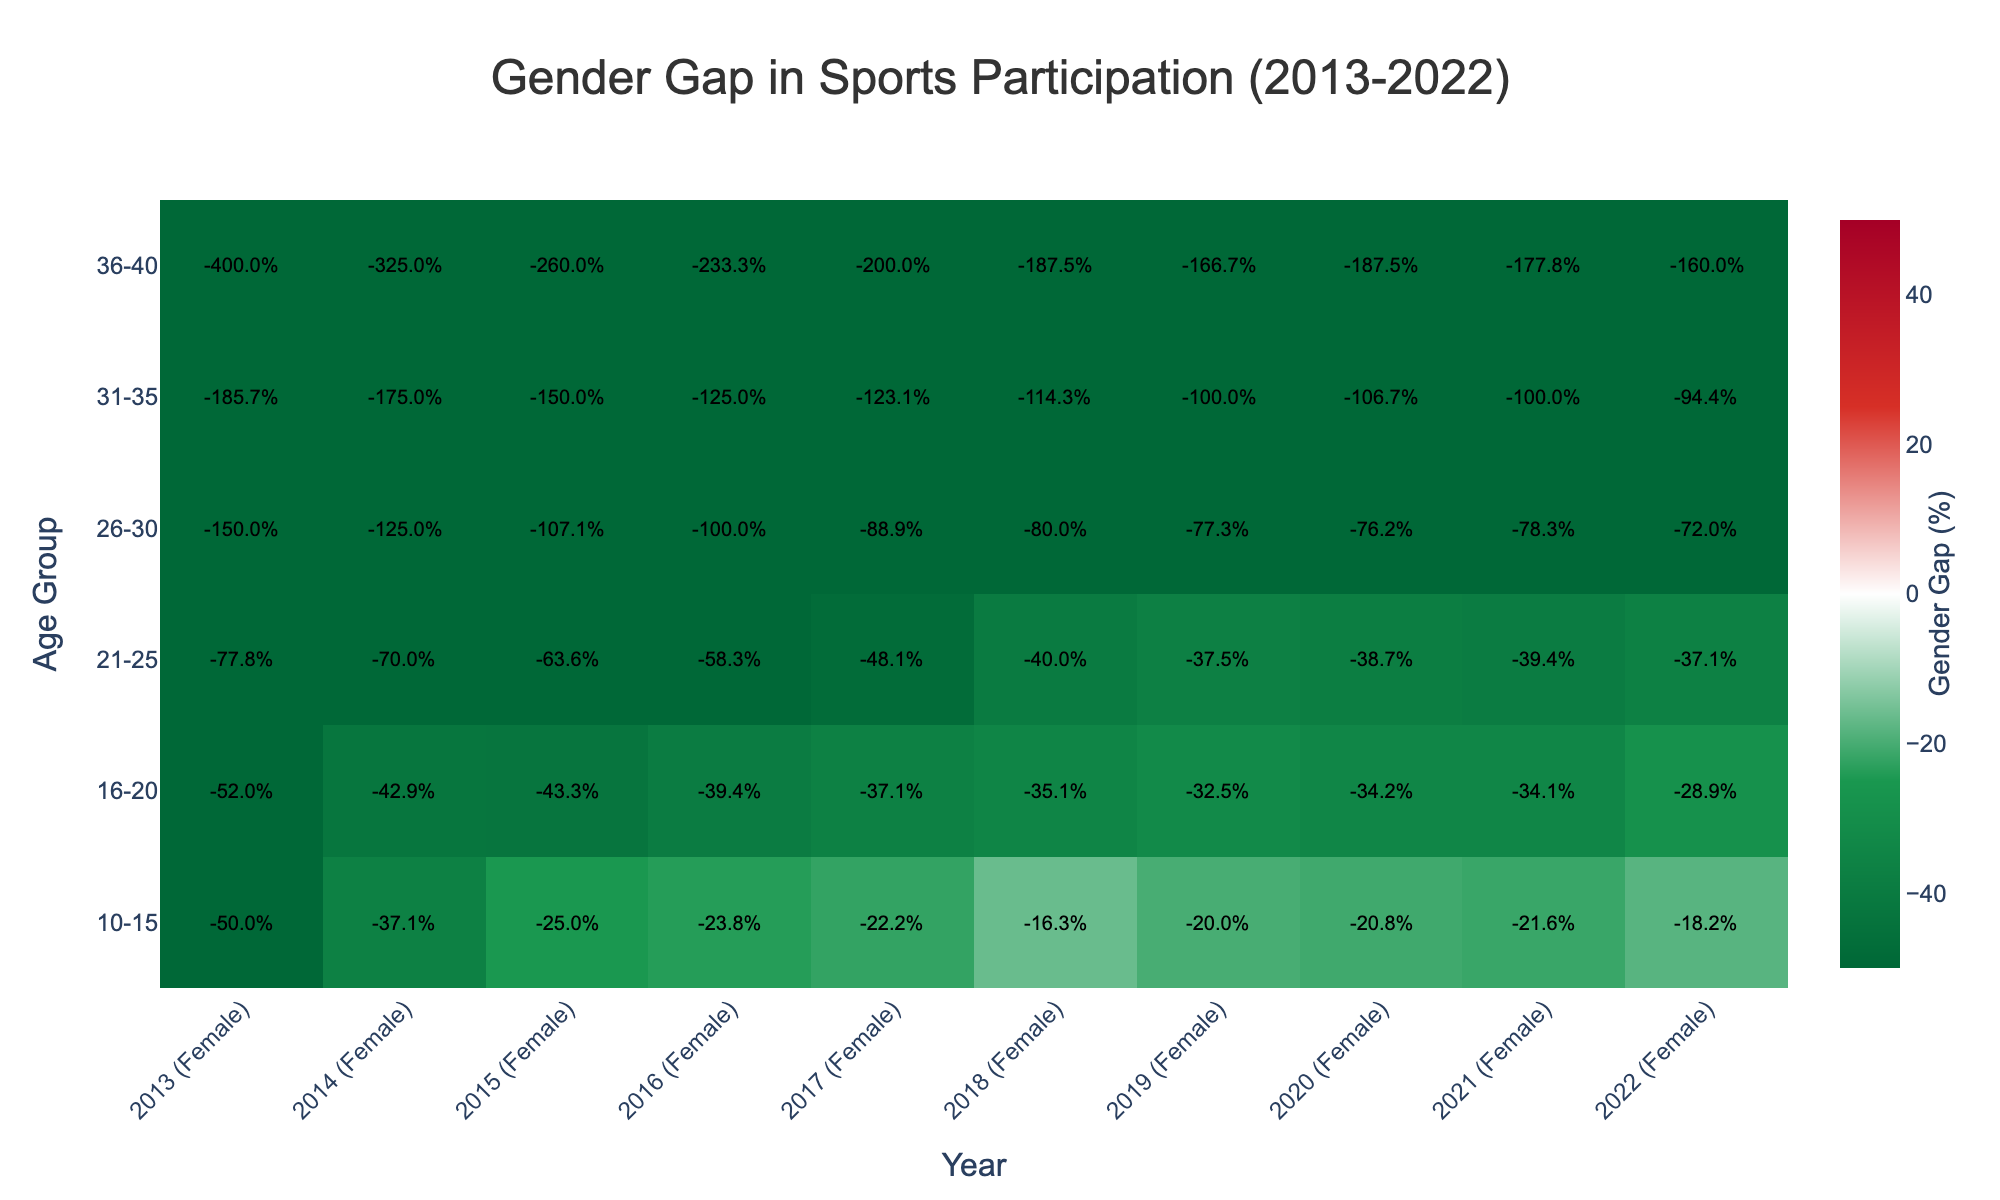What is the title of the heatmap? The title is typically found at the top of the figure and it summarizes the main topic or purpose of the visual representation. In this case, the title is "Gender Gap in Sports Participation (2013-2022)."
Answer: Gender Gap in Sports Participation (2013-2022) How are the years represented on the x-axis formatted? The x-axis in the heatmap lists the years in combination with the gender, formatted as "Year (Gender)." For example, you would see labels like "2013 (Male)" and "2013 (Female)." This indicates the gender-specific participation count for each year.
Answer: Year (Gender) Which age group shows the smallest gender gap in participation in 2013? To find this, locate the year 2013 on the x-axis and observe the values across different age groups. The smallest gender gap will be indicated by a value closest to 0%. From the figure, the 10-15 age group has a smaller gap compared to other age groups like 31-35 and 36-40.
Answer: 10-15 What age group has the highest percentage gender gap in 2022? Find the 2022 column on the x-axis and compare the percentage values across different age groups. The highest percentage gap will be the largest positive value. For 2022, the 36-40 age group shows the highest gap, around 61.5%.
Answer: 36-40 Compare the participation changes between males and females aged 21-25 from 2013 to 2022. What trend do you observe? Look at the heatmap and track the values from the 21-25 age group row over the years. Notice the color changes and annotations indicating the percentage gaps. From 2013 to 2022, although both male and female participation numbers have increased, the gender gap has generally decreased, indicating improved gender equality.
Answer: Decreasing gender gap What is the difference in gender gap percentages between age groups 10-15 and 36-40 in 2016? To find this, locate the 2016 column for both age groups and calculate the difference between their values. For 2016, the 10-15 age group has around 23.1%, and the 36-40 age group has around 70.0%. The difference is 70.0% - 23.1% = 46.9%.
Answer: 46.9% Which year had the most balanced participation between genders in the 26-30 age group? Locate the 26-30 age group row and observe the annotations for different years. The most balanced participation will be indicated by a value closest to 0%. For the 26-30 age group, the year 2020 shows the gender gap closest to zero at around 43.2%.
Answer: 2020 How does the gender gap trend in sports participation change from 2013 to 2022 for the 31-35 age group? Follow the 31-35 age group row across the years. Note the changes in values and colors. Over the years, there is a general trend of increasing participation overall, but the gender gap shows mixed fluctuations. It seems to slightly decrease towards 2022.
Answer: Slightly decreasing towards 2022 What does a dark red color on the heatmap indicate? Refer to the colorscale provided in the figure. Dark red represents the highest positive values in the gender gap, meaning a larger difference in male participation compared to female participation.
Answer: High positive gender gap 